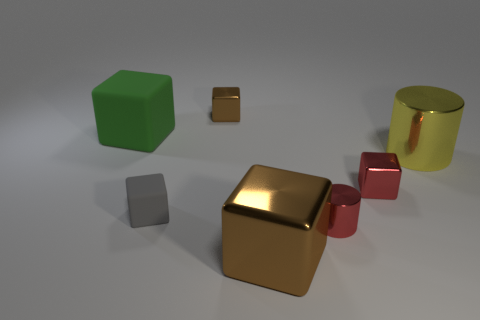Subtract 2 blocks. How many blocks are left? 3 Subtract all green cubes. How many cubes are left? 4 Subtract all big green rubber cubes. How many cubes are left? 4 Subtract all yellow blocks. Subtract all cyan spheres. How many blocks are left? 5 Add 1 tiny brown metallic objects. How many objects exist? 8 Subtract all cylinders. How many objects are left? 5 Add 3 large gray metallic blocks. How many large gray metallic blocks exist? 3 Subtract 1 brown cubes. How many objects are left? 6 Subtract all tiny cylinders. Subtract all purple objects. How many objects are left? 6 Add 1 small brown metallic objects. How many small brown metallic objects are left? 2 